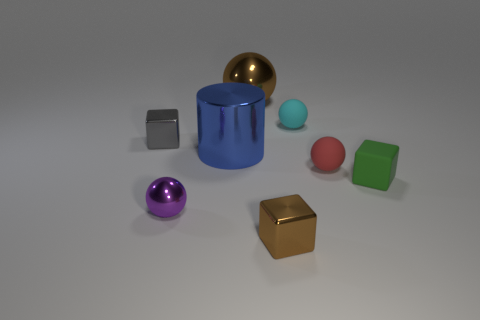Subtract 1 balls. How many balls are left? 3 Subtract all yellow balls. Subtract all yellow cylinders. How many balls are left? 4 Subtract all cylinders. How many objects are left? 7 Add 2 big gray spheres. How many big gray spheres exist? 2 Subtract 1 brown blocks. How many objects are left? 7 Subtract all brown things. Subtract all brown metallic things. How many objects are left? 4 Add 4 tiny green matte things. How many tiny green matte things are left? 5 